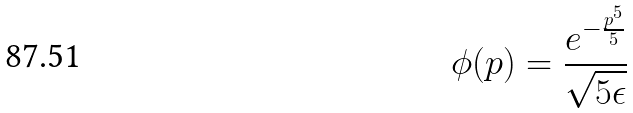<formula> <loc_0><loc_0><loc_500><loc_500>\phi ( p ) = \frac { e ^ { - \frac { p ^ { 5 } } { 5 } } } { \sqrt { 5 \epsilon } }</formula> 